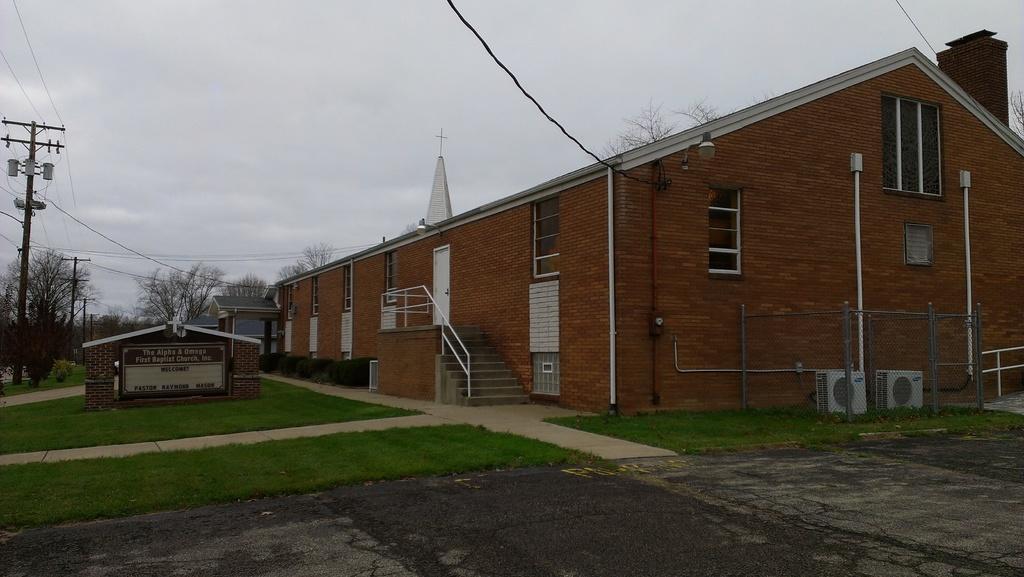Please provide a concise description of this image. In this image we can see a building with windows and doors with a staircase, metal barricade a fence and two air conditioners are placed on the ground. To the left side, we can see a signboard with some text on it, group of poles, trees and the sky. 